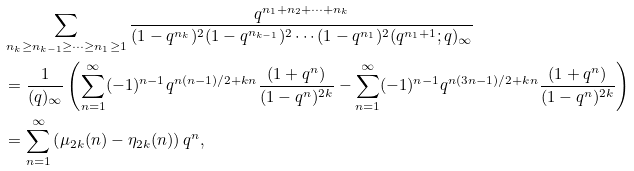<formula> <loc_0><loc_0><loc_500><loc_500>& \sum _ { n _ { k } \geq n _ { k - 1 } \geq \cdots \geq n _ { 1 } \geq 1 } \frac { q ^ { n _ { 1 } + n _ { 2 } + \cdots + n _ { k } } } { ( 1 - q ^ { n _ { k } } ) ^ { 2 } ( 1 - q ^ { n _ { k - 1 } } ) ^ { 2 } \cdots ( 1 - q ^ { n _ { 1 } } ) ^ { 2 } ( q ^ { n _ { 1 } + 1 } ; q ) _ { \infty } } \\ & = \frac { 1 } { ( q ) _ { \infty } } \left ( \sum _ { n = 1 } ^ { \infty } ( - 1 ) ^ { n - 1 } q ^ { n ( n - 1 ) / 2 + k n } \frac { ( 1 + q ^ { n } ) } { ( 1 - q ^ { n } ) ^ { 2 k } } - \sum _ { n = 1 } ^ { \infty } ( - 1 ) ^ { n - 1 } q ^ { n ( 3 n - 1 ) / 2 + k n } \frac { ( 1 + q ^ { n } ) } { ( 1 - q ^ { n } ) ^ { 2 k } } \right ) \\ & = \sum _ { n = 1 } ^ { \infty } \left ( \mu _ { 2 k } ( n ) - \eta _ { 2 k } ( n ) \right ) q ^ { n } ,</formula> 